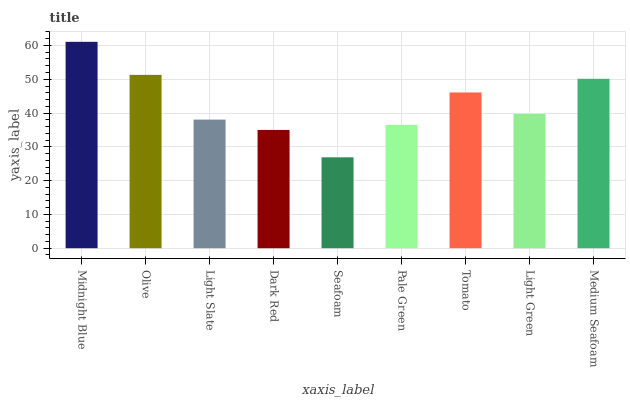Is Seafoam the minimum?
Answer yes or no. Yes. Is Midnight Blue the maximum?
Answer yes or no. Yes. Is Olive the minimum?
Answer yes or no. No. Is Olive the maximum?
Answer yes or no. No. Is Midnight Blue greater than Olive?
Answer yes or no. Yes. Is Olive less than Midnight Blue?
Answer yes or no. Yes. Is Olive greater than Midnight Blue?
Answer yes or no. No. Is Midnight Blue less than Olive?
Answer yes or no. No. Is Light Green the high median?
Answer yes or no. Yes. Is Light Green the low median?
Answer yes or no. Yes. Is Light Slate the high median?
Answer yes or no. No. Is Seafoam the low median?
Answer yes or no. No. 